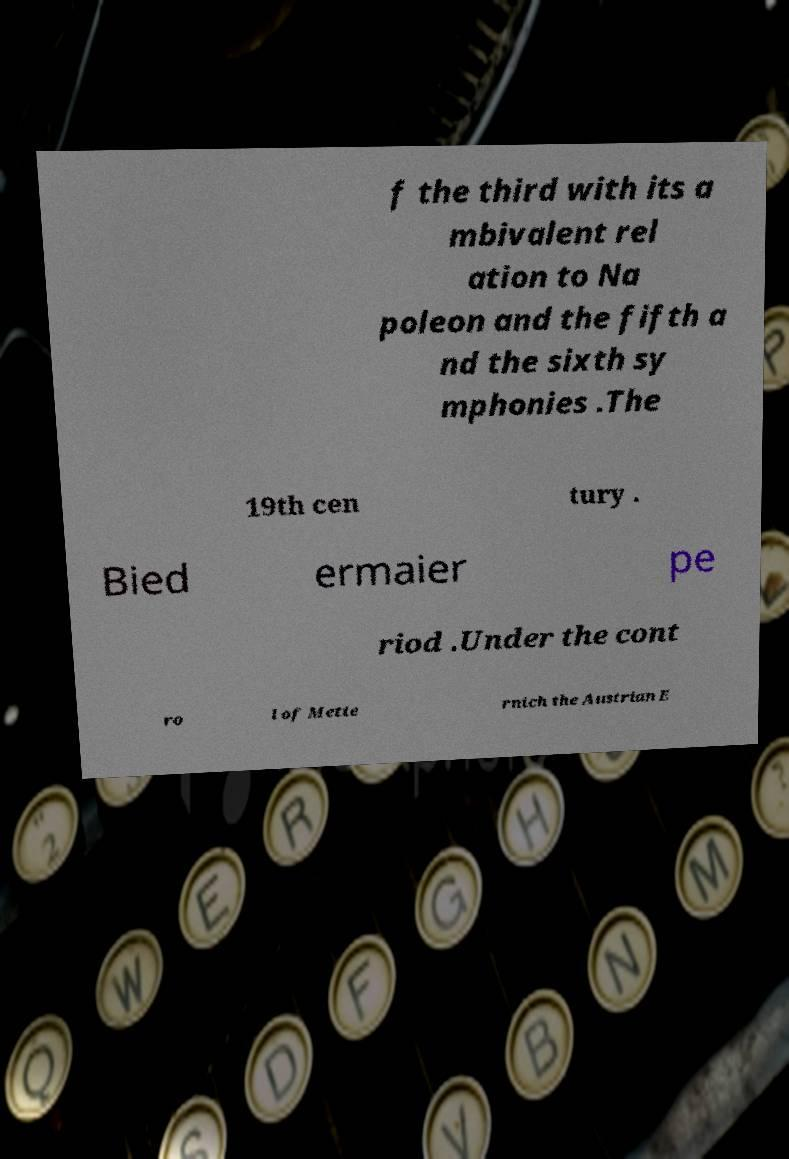Could you assist in decoding the text presented in this image and type it out clearly? f the third with its a mbivalent rel ation to Na poleon and the fifth a nd the sixth sy mphonies .The 19th cen tury . Bied ermaier pe riod .Under the cont ro l of Mette rnich the Austrian E 